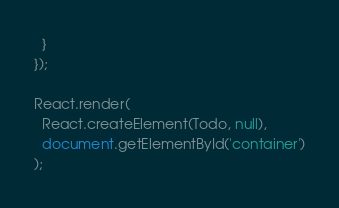Convert code to text. <code><loc_0><loc_0><loc_500><loc_500><_JavaScript_>  }
});

React.render(
  React.createElement(Todo, null),
  document.getElementById('container')
);</code> 